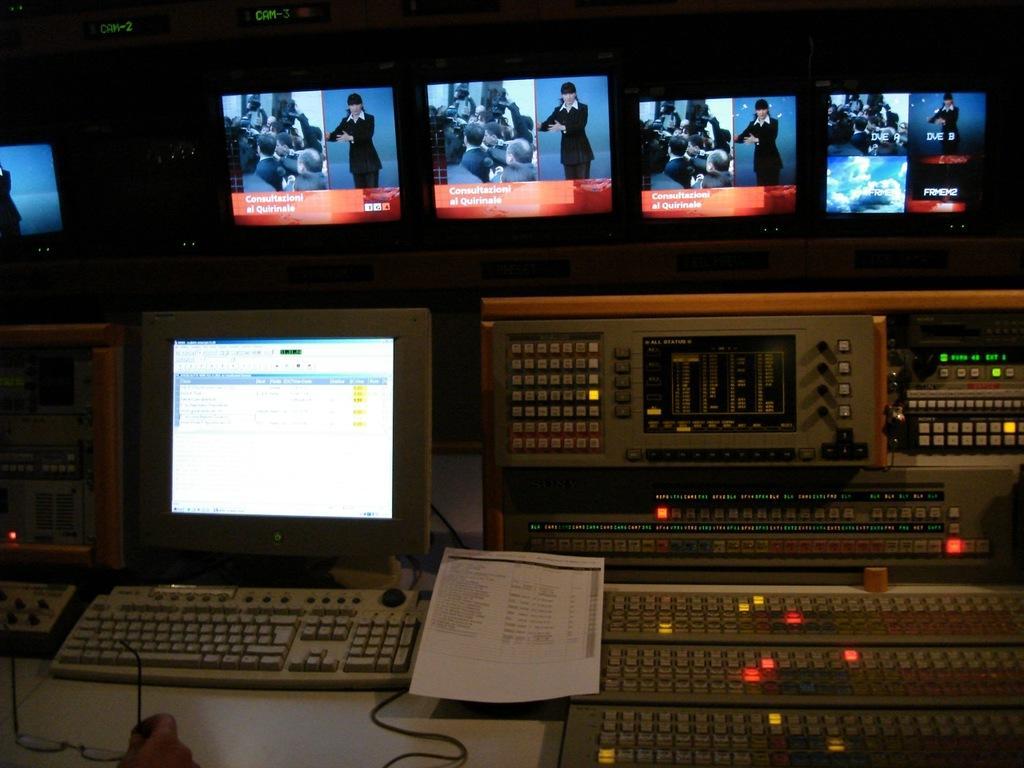Describe this image in one or two sentences. In this image I can see the white colored desk, a person's hand holding the spectacles. I can see few keyboards, few monitors and an electronic system to the right side of the image. I can see few papers on the desk. 